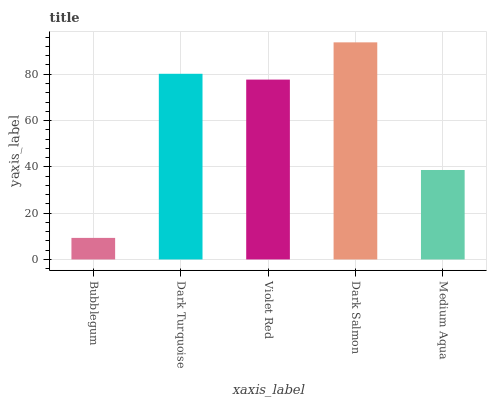Is Bubblegum the minimum?
Answer yes or no. Yes. Is Dark Salmon the maximum?
Answer yes or no. Yes. Is Dark Turquoise the minimum?
Answer yes or no. No. Is Dark Turquoise the maximum?
Answer yes or no. No. Is Dark Turquoise greater than Bubblegum?
Answer yes or no. Yes. Is Bubblegum less than Dark Turquoise?
Answer yes or no. Yes. Is Bubblegum greater than Dark Turquoise?
Answer yes or no. No. Is Dark Turquoise less than Bubblegum?
Answer yes or no. No. Is Violet Red the high median?
Answer yes or no. Yes. Is Violet Red the low median?
Answer yes or no. Yes. Is Dark Salmon the high median?
Answer yes or no. No. Is Dark Turquoise the low median?
Answer yes or no. No. 